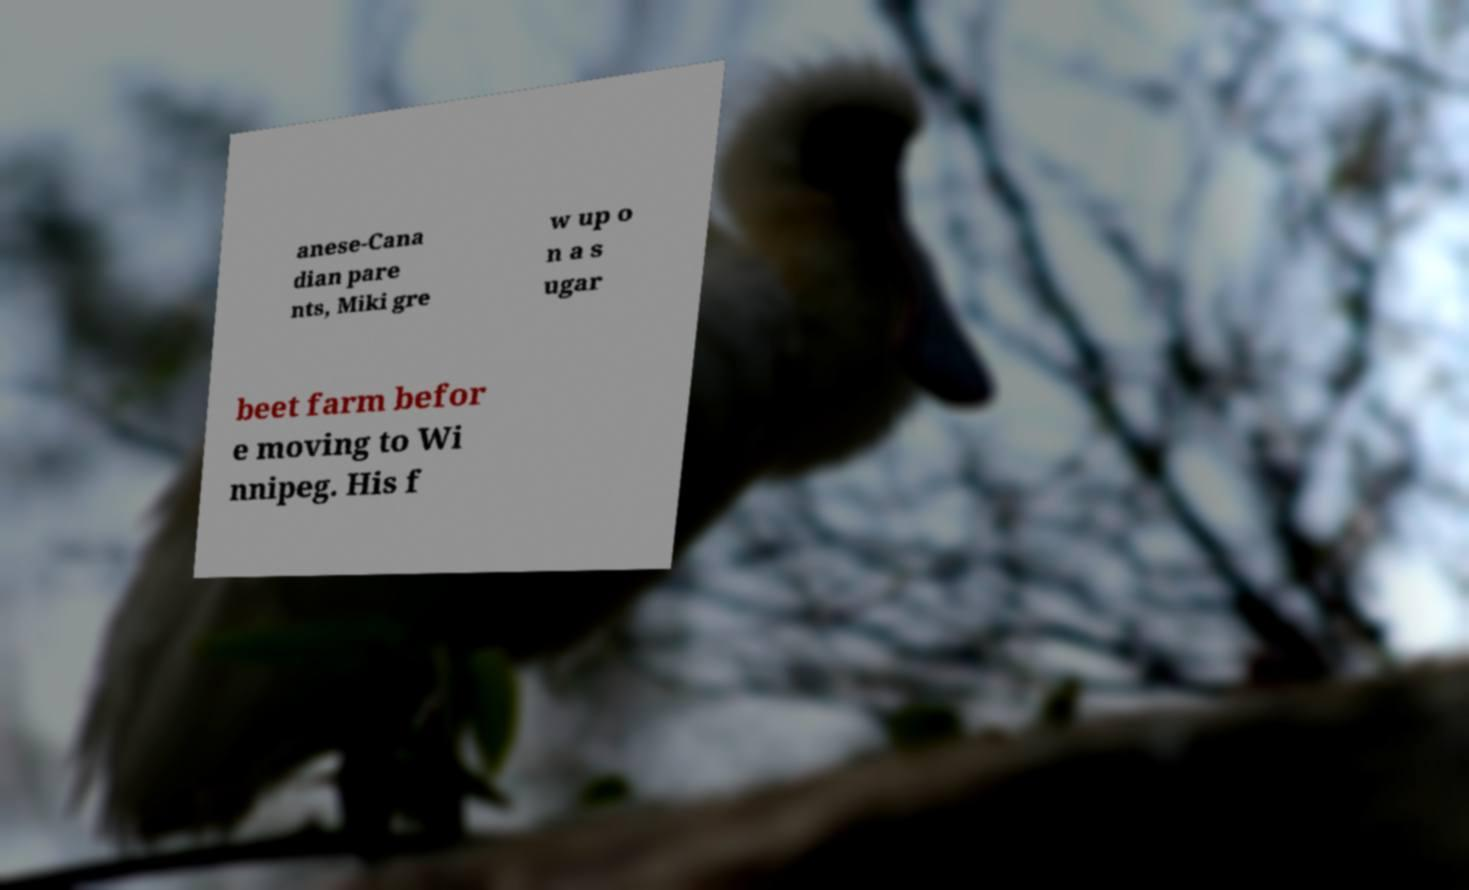Could you extract and type out the text from this image? anese-Cana dian pare nts, Miki gre w up o n a s ugar beet farm befor e moving to Wi nnipeg. His f 